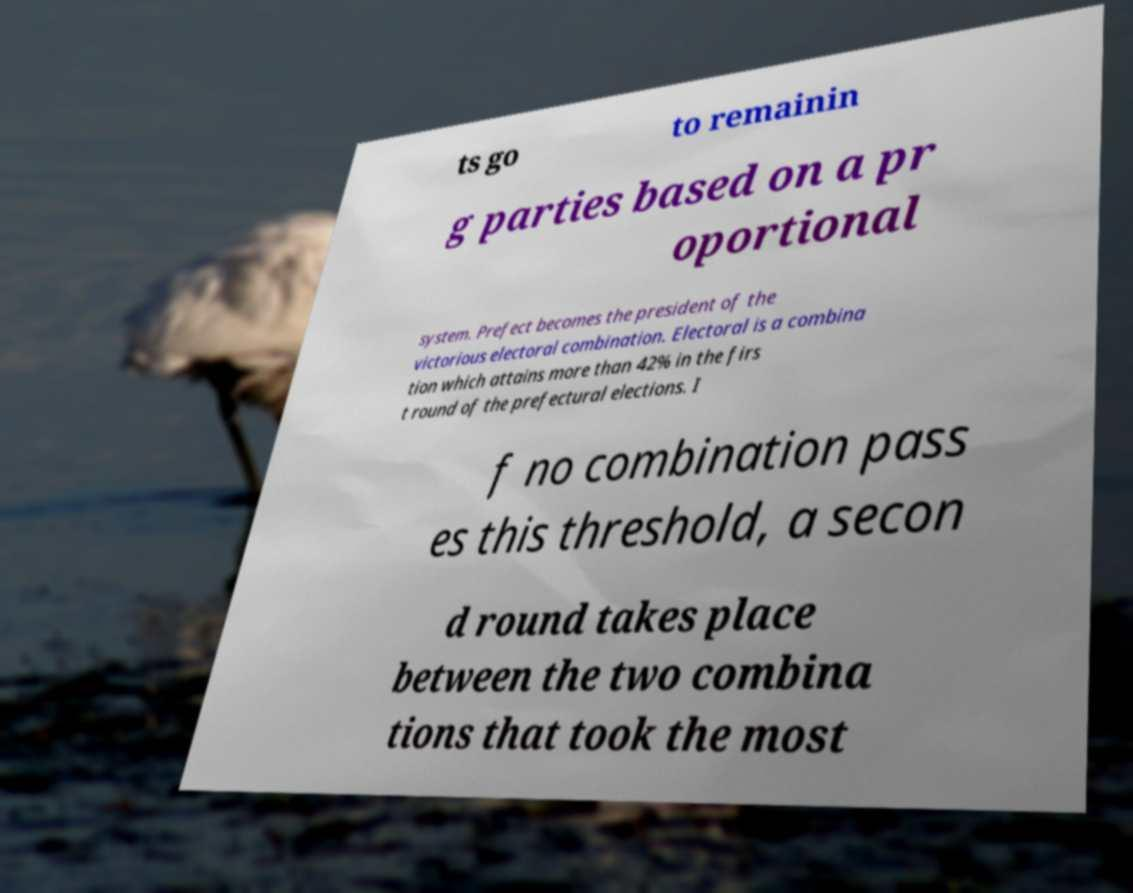Can you read and provide the text displayed in the image?This photo seems to have some interesting text. Can you extract and type it out for me? ts go to remainin g parties based on a pr oportional system. Prefect becomes the president of the victorious electoral combination. Electoral is a combina tion which attains more than 42% in the firs t round of the prefectural elections. I f no combination pass es this threshold, a secon d round takes place between the two combina tions that took the most 